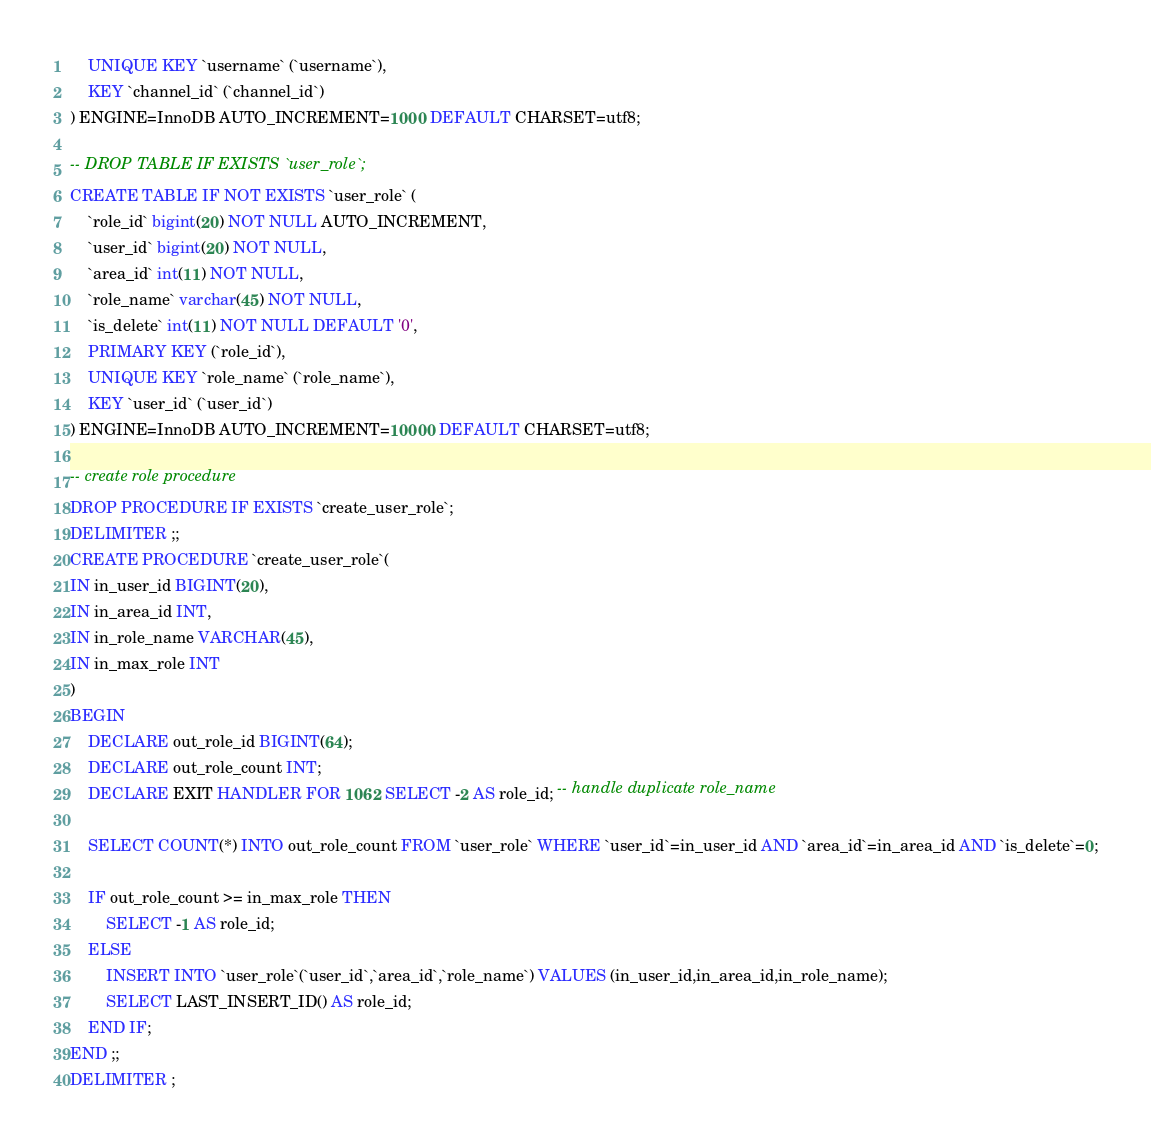<code> <loc_0><loc_0><loc_500><loc_500><_SQL_>	UNIQUE KEY `username` (`username`),
	KEY `channel_id` (`channel_id`)
) ENGINE=InnoDB AUTO_INCREMENT=1000 DEFAULT CHARSET=utf8;

-- DROP TABLE IF EXISTS `user_role`;
CREATE TABLE IF NOT EXISTS `user_role` (
	`role_id` bigint(20) NOT NULL AUTO_INCREMENT,
	`user_id` bigint(20) NOT NULL,
	`area_id` int(11) NOT NULL,
	`role_name` varchar(45) NOT NULL,
	`is_delete` int(11) NOT NULL DEFAULT '0',
	PRIMARY KEY (`role_id`),
	UNIQUE KEY `role_name` (`role_name`),
	KEY `user_id` (`user_id`)
) ENGINE=InnoDB AUTO_INCREMENT=10000 DEFAULT CHARSET=utf8;

-- create role procedure
DROP PROCEDURE IF EXISTS `create_user_role`;
DELIMITER ;;
CREATE PROCEDURE `create_user_role`(
IN in_user_id BIGINT(20),
IN in_area_id INT,
IN in_role_name VARCHAR(45),
IN in_max_role INT
)
BEGIN
	DECLARE out_role_id BIGINT(64);
	DECLARE out_role_count INT;
	DECLARE EXIT HANDLER FOR 1062 SELECT -2 AS role_id; -- handle duplicate role_name 
	
	SELECT COUNT(*) INTO out_role_count FROM `user_role` WHERE `user_id`=in_user_id AND `area_id`=in_area_id AND `is_delete`=0;

	IF out_role_count >= in_max_role THEN
		SELECT -1 AS role_id;
	ELSE
		INSERT INTO `user_role`(`user_id`,`area_id`,`role_name`) VALUES (in_user_id,in_area_id,in_role_name);
		SELECT LAST_INSERT_ID() AS role_id;
	END IF;
END ;;
DELIMITER ;
</code> 